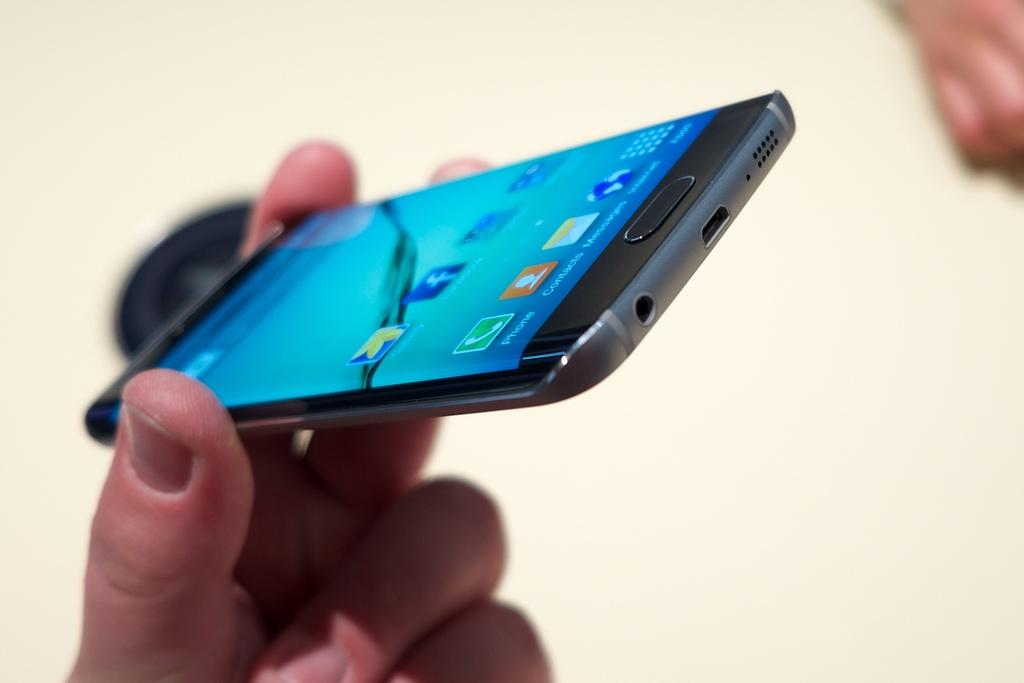What is the human hand holding in the image? A human hand is holding a mobile device in the image. What can be seen on the mobile screen? There are icons visible on the mobile screen. What is the color of the background in the image? The background of the image is white. How many apples are visible on the human hand in the image? There are no apples visible on the human hand in the image. What fact can be determined about the watch in the image? There is no watch present in the image. 